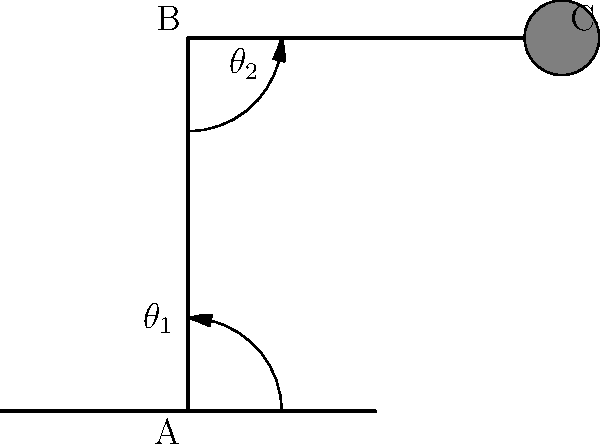Based on the 2D schematic of a robot arm shown above, what type of kinematic configuration does this represent? Additionally, how many degrees of freedom (DOF) does this arm possess? To determine the kinematic configuration and degrees of freedom of the robot arm, let's analyze the schematic step-by-step:

1. Arm structure:
   - The arm consists of two main segments (AB and BC) connected by revolute joints.
   - There's a base (point A) and an end-effector (point C).

2. Joint types:
   - We can see two angular measurements ($\theta_1$ and $\theta_2$), indicating two revolute joints.
   - The first joint allows rotation around point A in the vertical plane.
   - The second joint allows rotation around point B in the same plane.

3. Kinematic configuration:
   - This configuration is known as a "2R planar manipulator" or "RR planar robot."
   - "R" stands for revolute joint, and there are two of them in series.
   - The motion is confined to a single plane (2D movement).

4. Degrees of Freedom (DOF):
   - In robotics, DOF refers to the number of independent parameters that define the robot's configuration.
   - For this planar arm, we have:
     a) $\theta_1$: angle of the first joint
     b) $\theta_2$: angle of the second joint
   - Each of these angles can be controlled independently.
   - Therefore, this arm has 2 degrees of freedom.

5. Workspace:
   - The arm can reach any point within a circular area around its base, with some limitations due to joint constraints.
   - This type of arm is commonly used in 2D pick-and-place operations or for educational purposes in robotics.

In conclusion, this schematic represents a 2R planar manipulator with 2 degrees of freedom.
Answer: 2R planar manipulator with 2 DOF 